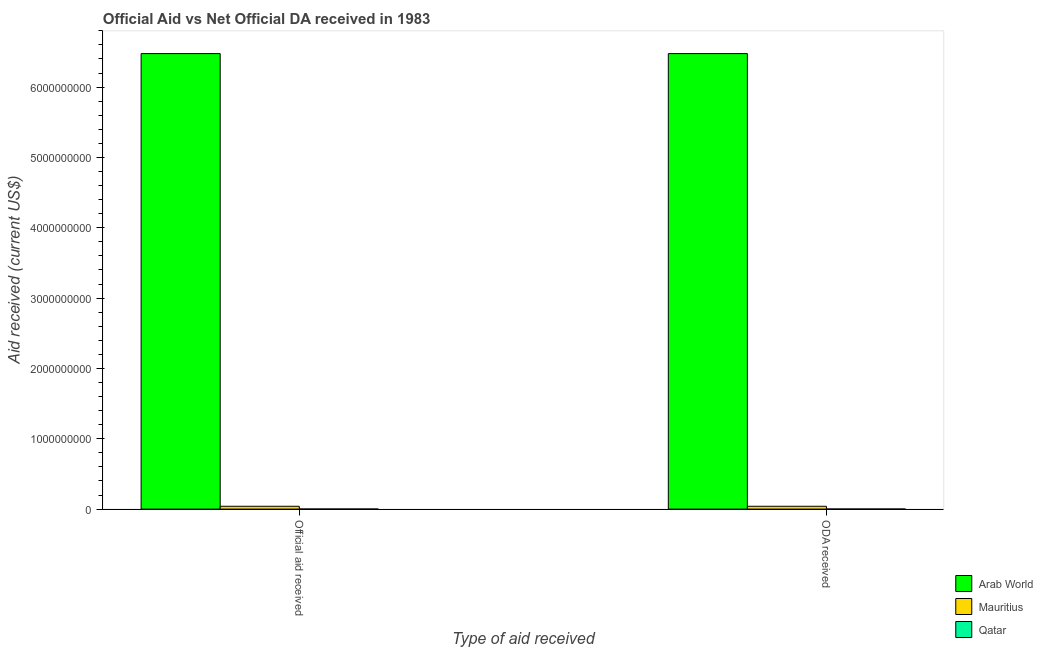How many different coloured bars are there?
Offer a very short reply. 3. How many groups of bars are there?
Provide a succinct answer. 2. Are the number of bars on each tick of the X-axis equal?
Give a very brief answer. Yes. What is the label of the 1st group of bars from the left?
Make the answer very short. Official aid received. What is the official aid received in Arab World?
Your answer should be very brief. 6.48e+09. Across all countries, what is the maximum official aid received?
Provide a short and direct response. 6.48e+09. Across all countries, what is the minimum oda received?
Your answer should be compact. 1.05e+06. In which country was the official aid received maximum?
Your response must be concise. Arab World. In which country was the official aid received minimum?
Ensure brevity in your answer.  Qatar. What is the total official aid received in the graph?
Keep it short and to the point. 6.52e+09. What is the difference between the oda received in Arab World and that in Mauritius?
Offer a very short reply. 6.44e+09. What is the difference between the official aid received in Qatar and the oda received in Mauritius?
Provide a succinct answer. -3.91e+07. What is the average official aid received per country?
Offer a terse response. 2.17e+09. In how many countries, is the official aid received greater than 2800000000 US$?
Ensure brevity in your answer.  1. What is the ratio of the oda received in Arab World to that in Mauritius?
Offer a very short reply. 161.35. Is the official aid received in Qatar less than that in Arab World?
Make the answer very short. Yes. In how many countries, is the official aid received greater than the average official aid received taken over all countries?
Keep it short and to the point. 1. What does the 1st bar from the left in ODA received represents?
Make the answer very short. Arab World. What does the 1st bar from the right in ODA received represents?
Provide a short and direct response. Qatar. How many bars are there?
Offer a terse response. 6. Are all the bars in the graph horizontal?
Your response must be concise. No. How many countries are there in the graph?
Your answer should be compact. 3. Does the graph contain any zero values?
Your response must be concise. No. Where does the legend appear in the graph?
Offer a very short reply. Bottom right. How many legend labels are there?
Make the answer very short. 3. How are the legend labels stacked?
Make the answer very short. Vertical. What is the title of the graph?
Keep it short and to the point. Official Aid vs Net Official DA received in 1983 . What is the label or title of the X-axis?
Your response must be concise. Type of aid received. What is the label or title of the Y-axis?
Your answer should be compact. Aid received (current US$). What is the Aid received (current US$) in Arab World in Official aid received?
Provide a short and direct response. 6.48e+09. What is the Aid received (current US$) of Mauritius in Official aid received?
Your response must be concise. 4.01e+07. What is the Aid received (current US$) of Qatar in Official aid received?
Your answer should be very brief. 1.05e+06. What is the Aid received (current US$) in Arab World in ODA received?
Make the answer very short. 6.48e+09. What is the Aid received (current US$) in Mauritius in ODA received?
Your answer should be compact. 4.01e+07. What is the Aid received (current US$) in Qatar in ODA received?
Keep it short and to the point. 1.05e+06. Across all Type of aid received, what is the maximum Aid received (current US$) in Arab World?
Provide a short and direct response. 6.48e+09. Across all Type of aid received, what is the maximum Aid received (current US$) in Mauritius?
Your response must be concise. 4.01e+07. Across all Type of aid received, what is the maximum Aid received (current US$) in Qatar?
Your answer should be very brief. 1.05e+06. Across all Type of aid received, what is the minimum Aid received (current US$) of Arab World?
Your answer should be very brief. 6.48e+09. Across all Type of aid received, what is the minimum Aid received (current US$) in Mauritius?
Your response must be concise. 4.01e+07. Across all Type of aid received, what is the minimum Aid received (current US$) of Qatar?
Offer a very short reply. 1.05e+06. What is the total Aid received (current US$) of Arab World in the graph?
Ensure brevity in your answer.  1.30e+1. What is the total Aid received (current US$) of Mauritius in the graph?
Give a very brief answer. 8.03e+07. What is the total Aid received (current US$) in Qatar in the graph?
Your answer should be very brief. 2.10e+06. What is the difference between the Aid received (current US$) in Arab World in Official aid received and that in ODA received?
Your answer should be compact. 0. What is the difference between the Aid received (current US$) in Mauritius in Official aid received and that in ODA received?
Ensure brevity in your answer.  0. What is the difference between the Aid received (current US$) of Arab World in Official aid received and the Aid received (current US$) of Mauritius in ODA received?
Provide a succinct answer. 6.44e+09. What is the difference between the Aid received (current US$) of Arab World in Official aid received and the Aid received (current US$) of Qatar in ODA received?
Keep it short and to the point. 6.48e+09. What is the difference between the Aid received (current US$) of Mauritius in Official aid received and the Aid received (current US$) of Qatar in ODA received?
Give a very brief answer. 3.91e+07. What is the average Aid received (current US$) in Arab World per Type of aid received?
Your response must be concise. 6.48e+09. What is the average Aid received (current US$) of Mauritius per Type of aid received?
Your answer should be compact. 4.01e+07. What is the average Aid received (current US$) in Qatar per Type of aid received?
Your answer should be compact. 1.05e+06. What is the difference between the Aid received (current US$) in Arab World and Aid received (current US$) in Mauritius in Official aid received?
Your response must be concise. 6.44e+09. What is the difference between the Aid received (current US$) in Arab World and Aid received (current US$) in Qatar in Official aid received?
Ensure brevity in your answer.  6.48e+09. What is the difference between the Aid received (current US$) in Mauritius and Aid received (current US$) in Qatar in Official aid received?
Your answer should be very brief. 3.91e+07. What is the difference between the Aid received (current US$) of Arab World and Aid received (current US$) of Mauritius in ODA received?
Provide a short and direct response. 6.44e+09. What is the difference between the Aid received (current US$) of Arab World and Aid received (current US$) of Qatar in ODA received?
Offer a very short reply. 6.48e+09. What is the difference between the Aid received (current US$) of Mauritius and Aid received (current US$) of Qatar in ODA received?
Give a very brief answer. 3.91e+07. What is the ratio of the Aid received (current US$) of Arab World in Official aid received to that in ODA received?
Your answer should be very brief. 1. What is the ratio of the Aid received (current US$) in Qatar in Official aid received to that in ODA received?
Offer a terse response. 1. What is the difference between the highest and the second highest Aid received (current US$) in Qatar?
Provide a succinct answer. 0. What is the difference between the highest and the lowest Aid received (current US$) in Arab World?
Provide a succinct answer. 0. What is the difference between the highest and the lowest Aid received (current US$) of Mauritius?
Your answer should be compact. 0. What is the difference between the highest and the lowest Aid received (current US$) in Qatar?
Make the answer very short. 0. 